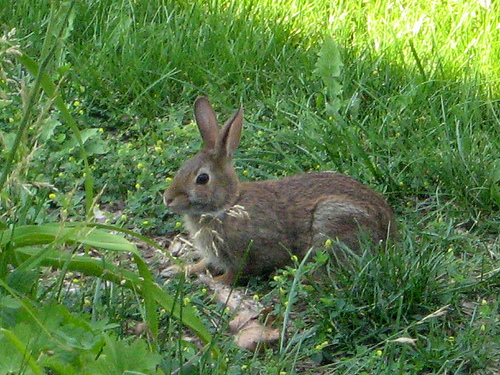<image>
Is there a rabbit behind the grass? Yes. From this viewpoint, the rabbit is positioned behind the grass, with the grass partially or fully occluding the rabbit. 